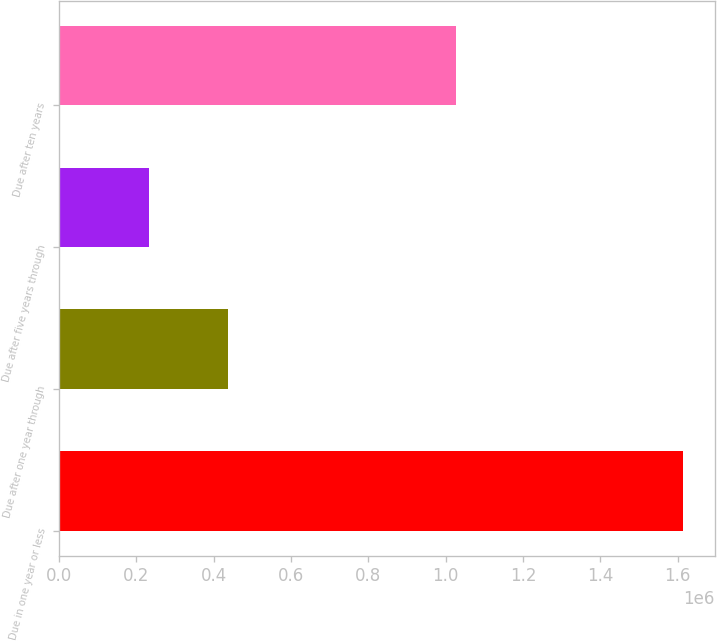Convert chart to OTSL. <chart><loc_0><loc_0><loc_500><loc_500><bar_chart><fcel>Due in one year or less<fcel>Due after one year through<fcel>Due after five years through<fcel>Due after ten years<nl><fcel>1.61456e+06<fcel>437854<fcel>231266<fcel>1.02772e+06<nl></chart> 